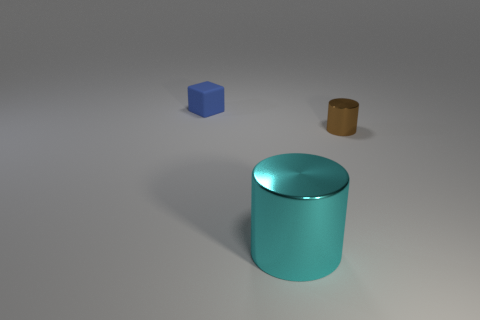Add 3 large yellow metal spheres. How many objects exist? 6 Subtract all cylinders. How many objects are left? 1 Subtract all large cyan things. Subtract all big things. How many objects are left? 1 Add 2 large cyan things. How many large cyan things are left? 3 Add 2 metallic cylinders. How many metallic cylinders exist? 4 Subtract 1 blue cubes. How many objects are left? 2 